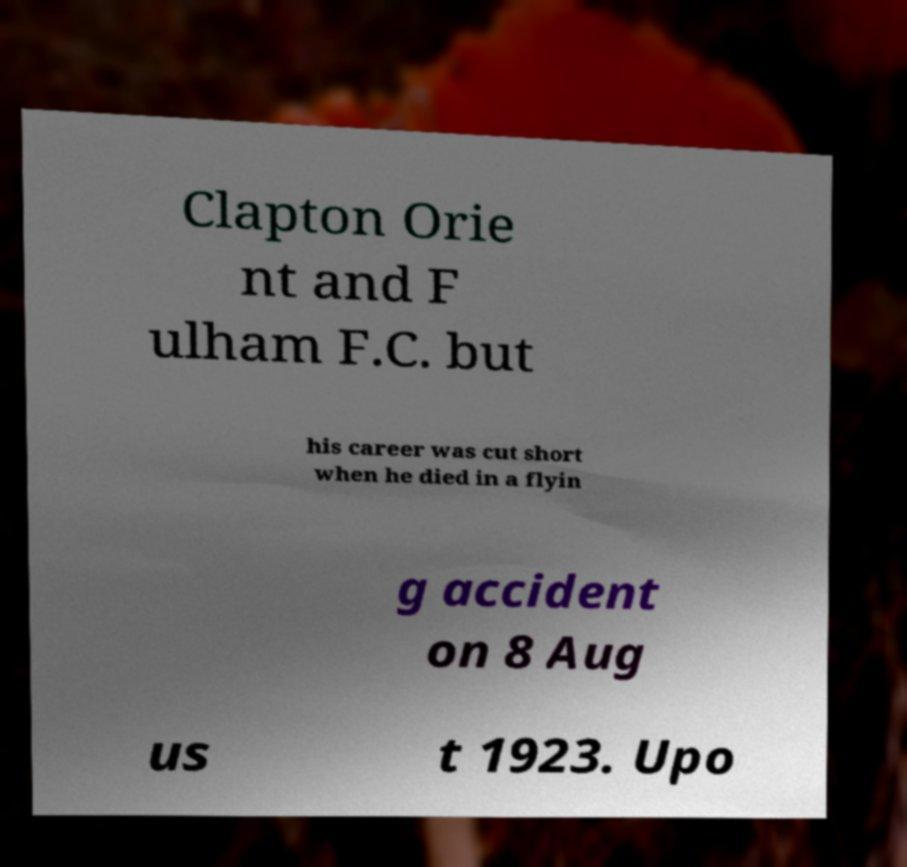Could you assist in decoding the text presented in this image and type it out clearly? Clapton Orie nt and F ulham F.C. but his career was cut short when he died in a flyin g accident on 8 Aug us t 1923. Upo 